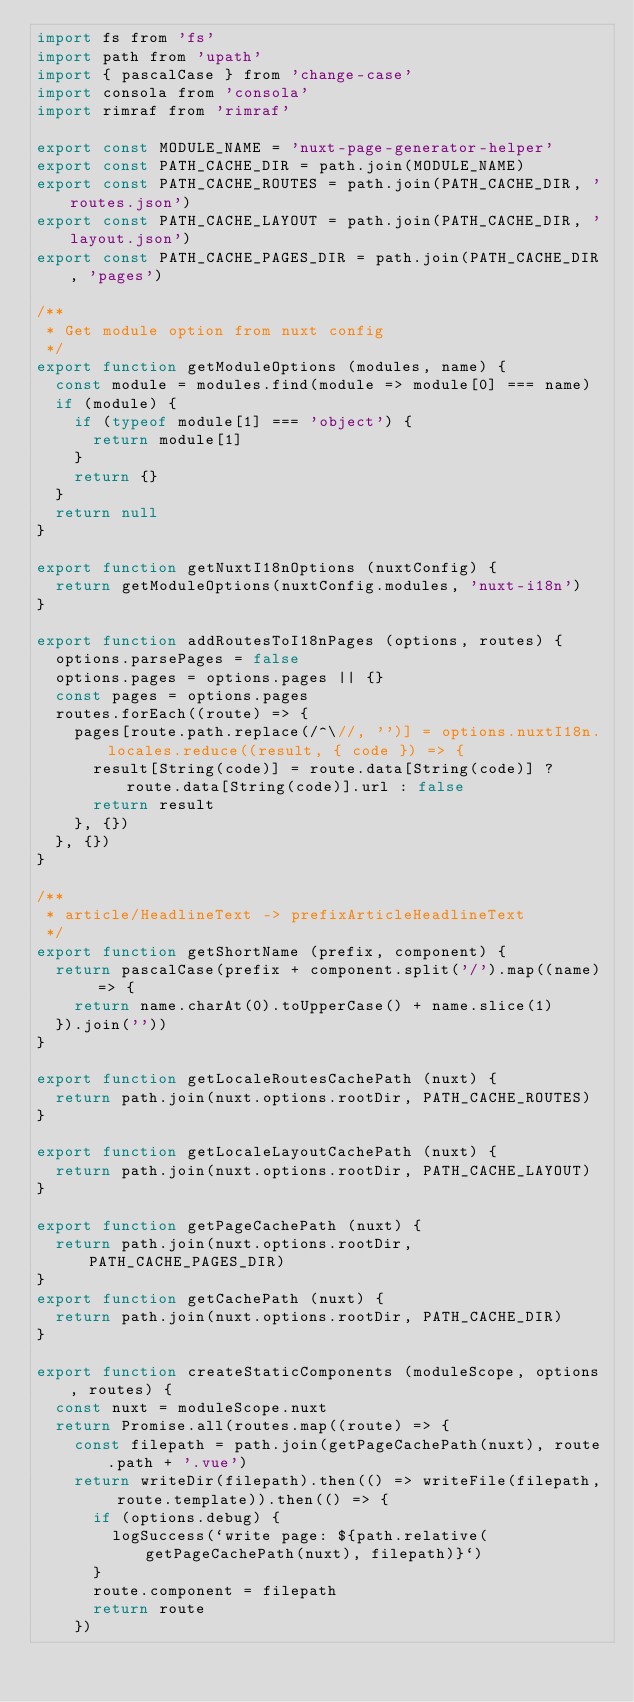Convert code to text. <code><loc_0><loc_0><loc_500><loc_500><_JavaScript_>import fs from 'fs'
import path from 'upath'
import { pascalCase } from 'change-case'
import consola from 'consola'
import rimraf from 'rimraf'

export const MODULE_NAME = 'nuxt-page-generator-helper'
export const PATH_CACHE_DIR = path.join(MODULE_NAME)
export const PATH_CACHE_ROUTES = path.join(PATH_CACHE_DIR, 'routes.json')
export const PATH_CACHE_LAYOUT = path.join(PATH_CACHE_DIR, 'layout.json')
export const PATH_CACHE_PAGES_DIR = path.join(PATH_CACHE_DIR, 'pages')

/**
 * Get module option from nuxt config
 */
export function getModuleOptions (modules, name) {
  const module = modules.find(module => module[0] === name)
  if (module) {
    if (typeof module[1] === 'object') {
      return module[1]
    }
    return {}
  }
  return null
}

export function getNuxtI18nOptions (nuxtConfig) {
  return getModuleOptions(nuxtConfig.modules, 'nuxt-i18n')
}

export function addRoutesToI18nPages (options, routes) {
  options.parsePages = false
  options.pages = options.pages || {}
  const pages = options.pages
  routes.forEach((route) => {
    pages[route.path.replace(/^\//, '')] = options.nuxtI18n.locales.reduce((result, { code }) => {
      result[String(code)] = route.data[String(code)] ? route.data[String(code)].url : false
      return result
    }, {})
  }, {})
}

/**
 * article/HeadlineText -> prefixArticleHeadlineText
 */
export function getShortName (prefix, component) {
  return pascalCase(prefix + component.split('/').map((name) => {
    return name.charAt(0).toUpperCase() + name.slice(1)
  }).join(''))
}

export function getLocaleRoutesCachePath (nuxt) {
  return path.join(nuxt.options.rootDir, PATH_CACHE_ROUTES)
}

export function getLocaleLayoutCachePath (nuxt) {
  return path.join(nuxt.options.rootDir, PATH_CACHE_LAYOUT)
}

export function getPageCachePath (nuxt) {
  return path.join(nuxt.options.rootDir, PATH_CACHE_PAGES_DIR)
}
export function getCachePath (nuxt) {
  return path.join(nuxt.options.rootDir, PATH_CACHE_DIR)
}

export function createStaticComponents (moduleScope, options, routes) {
  const nuxt = moduleScope.nuxt
  return Promise.all(routes.map((route) => {
    const filepath = path.join(getPageCachePath(nuxt), route.path + '.vue')
    return writeDir(filepath).then(() => writeFile(filepath, route.template)).then(() => {
      if (options.debug) {
        logSuccess(`write page: ${path.relative(getPageCachePath(nuxt), filepath)}`)
      }
      route.component = filepath
      return route
    })</code> 